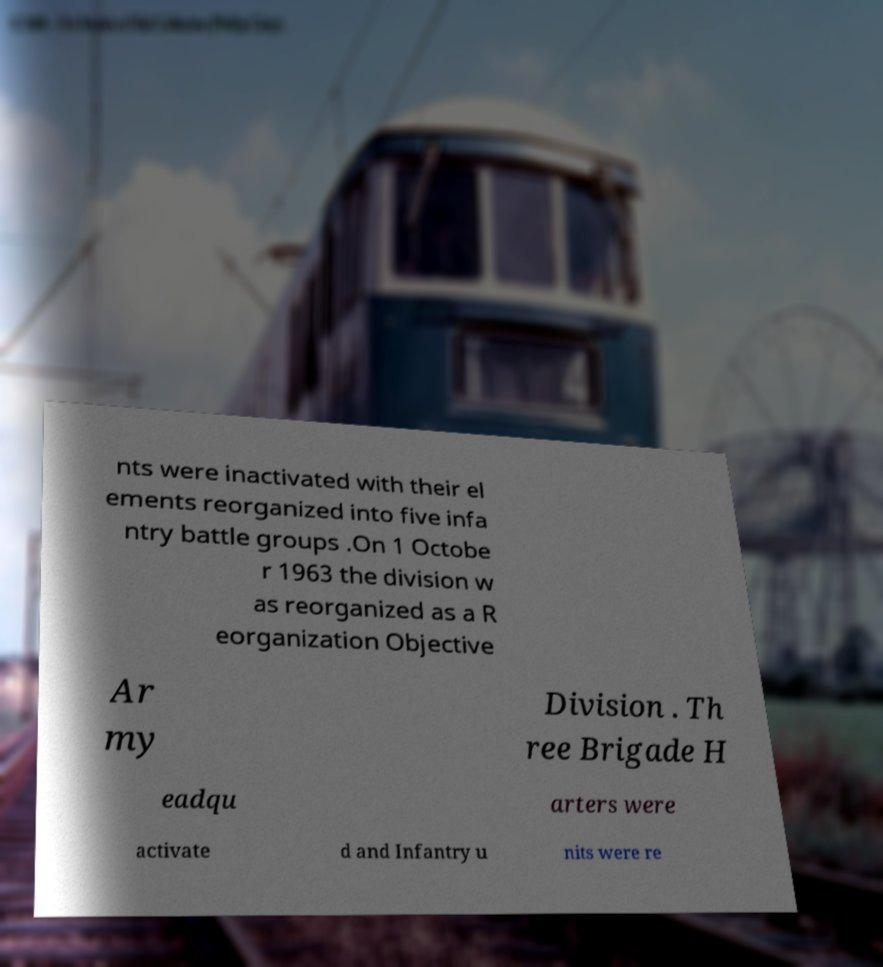Can you accurately transcribe the text from the provided image for me? nts were inactivated with their el ements reorganized into five infa ntry battle groups .On 1 Octobe r 1963 the division w as reorganized as a R eorganization Objective Ar my Division . Th ree Brigade H eadqu arters were activate d and Infantry u nits were re 